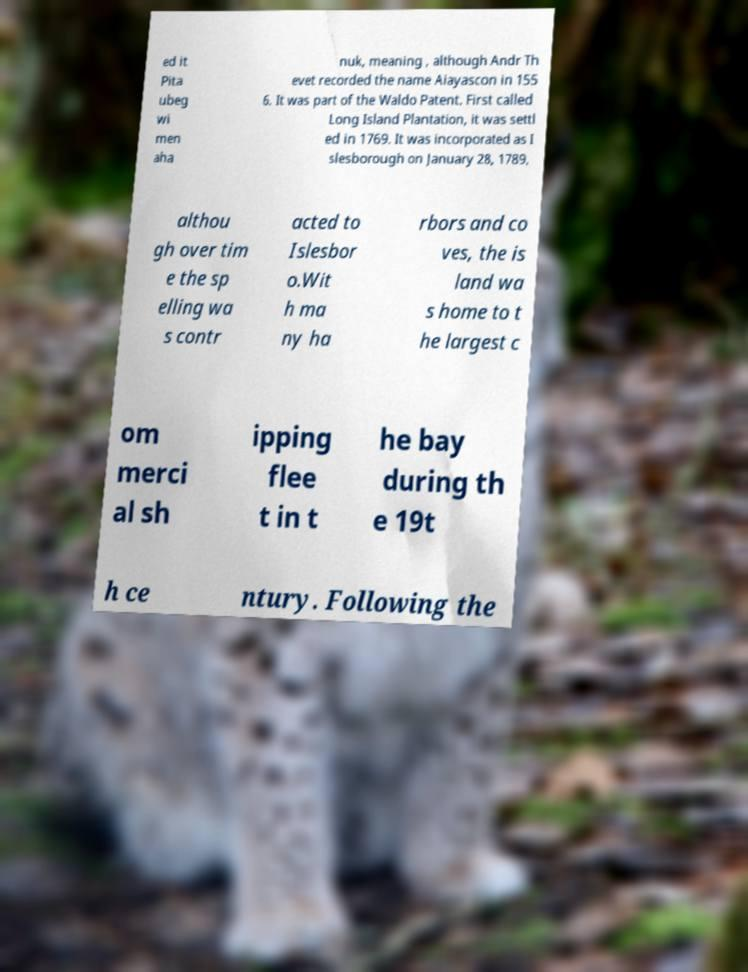Could you assist in decoding the text presented in this image and type it out clearly? ed it Pita ubeg wi men aha nuk, meaning , although Andr Th evet recorded the name Aiayascon in 155 6. It was part of the Waldo Patent. First called Long Island Plantation, it was settl ed in 1769. It was incorporated as I slesborough on January 28, 1789, althou gh over tim e the sp elling wa s contr acted to Islesbor o.Wit h ma ny ha rbors and co ves, the is land wa s home to t he largest c om merci al sh ipping flee t in t he bay during th e 19t h ce ntury. Following the 